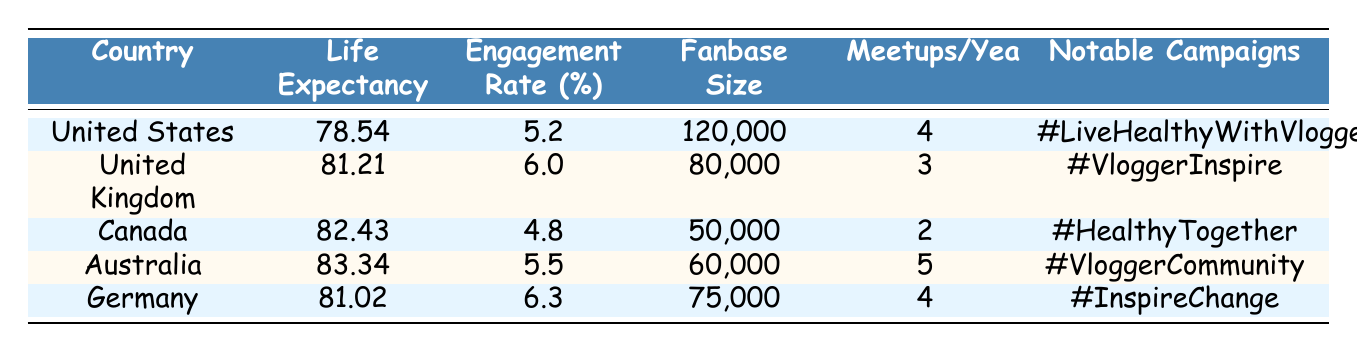What is the average life expectancy across all listed countries? To find the average life expectancy, I sum the average life expectancy values: 78.54 + 81.21 + 82.43 + 83.34 + 81.02 = 406.54. Then, divide by the number of countries (5): 406.54 / 5 = 81.31.
Answer: 81.31 Which country has the highest social media engagement rate? By reviewing the social media engagement rate column, the highest value is 6.3, which belongs to Germany.
Answer: Germany Is the average life expectancy of the United States greater than that of Canada? The average life expectancy in the United States is 78.54, and in Canada it is 82.43. Since 78.54 is less than 82.43, the statement is false.
Answer: No How many countries have a fanbase size greater than 70,000? I count the countries with fanbase sizes greater than 70,000: United States (120,000), United Kingdom (80,000), and Germany (75,000) make a total of 3 countries.
Answer: 3 What is the average meetup frequency per year for all countries? The total meetup frequency is calculated as: 4 + 3 + 2 + 5 + 4 = 18. Dividing by the number of countries (5) gives: 18 / 5 = 3.6.
Answer: 3.6 Do countries with larger fanbase sizes tend to have higher life expectancies? To answer this, let's examine the data: the U.S. has the largest fanbase and the lowest life expectancy (78.54). Canada has a smaller fanbase with a higher life expectancy (82.43). This suggests there is no clear correlation.
Answer: No Which country has the lowest social media engagement rate? By comparing the engagement rates, Canada has the lowest at 4.8.
Answer: Canada If we exclude the country with the lowest life expectancy, what is the new average life expectancy? The lowest life expectancy is from the U.S. (78.54). The remaining life expectancies are: 81.21, 82.43, 83.34, and 81.02. The sum is 328. These 4 values give an average of 328 / 4 = 82.
Answer: 82 